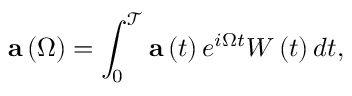Convert formula to latex. <formula><loc_0><loc_0><loc_500><loc_500>a \left ( \Omega \right ) = \int _ { 0 } ^ { \mathcal { T } } a \left ( t \right ) e ^ { i \Omega t } W \left ( t \right ) d t ,</formula> 